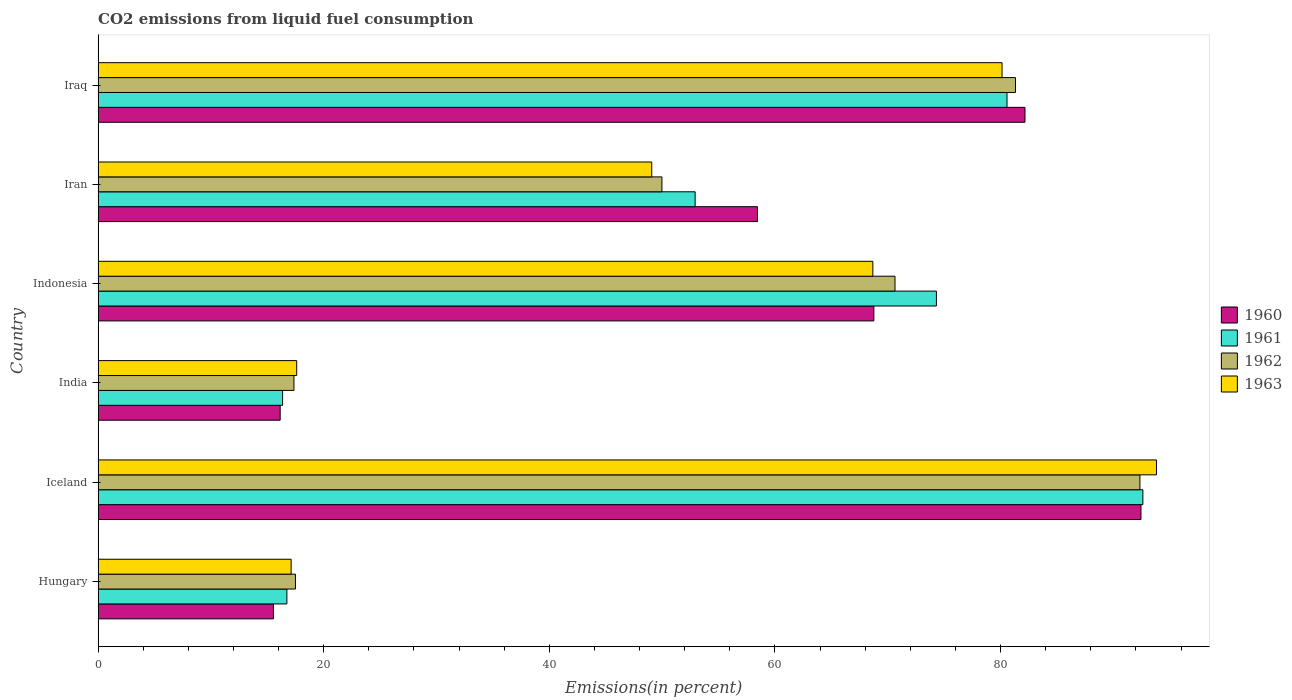How many bars are there on the 2nd tick from the top?
Ensure brevity in your answer.  4. How many bars are there on the 1st tick from the bottom?
Offer a terse response. 4. What is the label of the 1st group of bars from the top?
Your answer should be compact. Iraq. What is the total CO2 emitted in 1961 in Iran?
Make the answer very short. 52.93. Across all countries, what is the maximum total CO2 emitted in 1960?
Ensure brevity in your answer.  92.45. Across all countries, what is the minimum total CO2 emitted in 1961?
Provide a short and direct response. 16.35. In which country was the total CO2 emitted in 1960 maximum?
Your response must be concise. Iceland. What is the total total CO2 emitted in 1961 in the graph?
Your response must be concise. 333.52. What is the difference between the total CO2 emitted in 1962 in India and that in Iraq?
Offer a terse response. -63.96. What is the difference between the total CO2 emitted in 1961 in Iraq and the total CO2 emitted in 1962 in Indonesia?
Keep it short and to the point. 9.93. What is the average total CO2 emitted in 1960 per country?
Provide a succinct answer. 55.58. What is the difference between the total CO2 emitted in 1960 and total CO2 emitted in 1963 in Iceland?
Offer a very short reply. -1.37. In how many countries, is the total CO2 emitted in 1960 greater than 28 %?
Give a very brief answer. 4. What is the ratio of the total CO2 emitted in 1961 in Indonesia to that in Iran?
Give a very brief answer. 1.4. Is the difference between the total CO2 emitted in 1960 in India and Iraq greater than the difference between the total CO2 emitted in 1963 in India and Iraq?
Your answer should be very brief. No. What is the difference between the highest and the second highest total CO2 emitted in 1961?
Your answer should be compact. 12.05. What is the difference between the highest and the lowest total CO2 emitted in 1960?
Provide a succinct answer. 76.91. Is the sum of the total CO2 emitted in 1963 in Hungary and Indonesia greater than the maximum total CO2 emitted in 1962 across all countries?
Your response must be concise. No. Is it the case that in every country, the sum of the total CO2 emitted in 1960 and total CO2 emitted in 1961 is greater than the sum of total CO2 emitted in 1962 and total CO2 emitted in 1963?
Provide a succinct answer. No. Is it the case that in every country, the sum of the total CO2 emitted in 1963 and total CO2 emitted in 1961 is greater than the total CO2 emitted in 1962?
Provide a short and direct response. Yes. How many countries are there in the graph?
Give a very brief answer. 6. What is the difference between two consecutive major ticks on the X-axis?
Your response must be concise. 20. Does the graph contain grids?
Offer a terse response. No. What is the title of the graph?
Offer a terse response. CO2 emissions from liquid fuel consumption. Does "1983" appear as one of the legend labels in the graph?
Ensure brevity in your answer.  No. What is the label or title of the X-axis?
Provide a short and direct response. Emissions(in percent). What is the label or title of the Y-axis?
Make the answer very short. Country. What is the Emissions(in percent) of 1960 in Hungary?
Keep it short and to the point. 15.54. What is the Emissions(in percent) of 1961 in Hungary?
Make the answer very short. 16.73. What is the Emissions(in percent) of 1962 in Hungary?
Keep it short and to the point. 17.49. What is the Emissions(in percent) of 1963 in Hungary?
Your answer should be compact. 17.11. What is the Emissions(in percent) in 1960 in Iceland?
Offer a terse response. 92.45. What is the Emissions(in percent) in 1961 in Iceland?
Ensure brevity in your answer.  92.62. What is the Emissions(in percent) of 1962 in Iceland?
Provide a short and direct response. 92.35. What is the Emissions(in percent) of 1963 in Iceland?
Ensure brevity in your answer.  93.82. What is the Emissions(in percent) in 1960 in India?
Your answer should be very brief. 16.14. What is the Emissions(in percent) in 1961 in India?
Ensure brevity in your answer.  16.35. What is the Emissions(in percent) in 1962 in India?
Provide a succinct answer. 17.36. What is the Emissions(in percent) of 1963 in India?
Provide a succinct answer. 17.61. What is the Emissions(in percent) of 1960 in Indonesia?
Your answer should be very brief. 68.77. What is the Emissions(in percent) in 1961 in Indonesia?
Your answer should be very brief. 74.31. What is the Emissions(in percent) in 1962 in Indonesia?
Provide a succinct answer. 70.64. What is the Emissions(in percent) in 1963 in Indonesia?
Offer a terse response. 68.68. What is the Emissions(in percent) of 1960 in Iran?
Make the answer very short. 58.45. What is the Emissions(in percent) in 1961 in Iran?
Offer a terse response. 52.93. What is the Emissions(in percent) of 1962 in Iran?
Your response must be concise. 49.98. What is the Emissions(in percent) in 1963 in Iran?
Provide a short and direct response. 49.08. What is the Emissions(in percent) in 1960 in Iraq?
Your answer should be very brief. 82.17. What is the Emissions(in percent) of 1961 in Iraq?
Make the answer very short. 80.57. What is the Emissions(in percent) in 1962 in Iraq?
Provide a succinct answer. 81.32. What is the Emissions(in percent) in 1963 in Iraq?
Make the answer very short. 80.13. Across all countries, what is the maximum Emissions(in percent) of 1960?
Ensure brevity in your answer.  92.45. Across all countries, what is the maximum Emissions(in percent) in 1961?
Offer a very short reply. 92.62. Across all countries, what is the maximum Emissions(in percent) in 1962?
Offer a very short reply. 92.35. Across all countries, what is the maximum Emissions(in percent) of 1963?
Your answer should be compact. 93.82. Across all countries, what is the minimum Emissions(in percent) in 1960?
Provide a succinct answer. 15.54. Across all countries, what is the minimum Emissions(in percent) of 1961?
Offer a very short reply. 16.35. Across all countries, what is the minimum Emissions(in percent) of 1962?
Provide a succinct answer. 17.36. Across all countries, what is the minimum Emissions(in percent) of 1963?
Provide a succinct answer. 17.11. What is the total Emissions(in percent) in 1960 in the graph?
Make the answer very short. 333.51. What is the total Emissions(in percent) of 1961 in the graph?
Offer a very short reply. 333.52. What is the total Emissions(in percent) in 1962 in the graph?
Keep it short and to the point. 329.16. What is the total Emissions(in percent) in 1963 in the graph?
Ensure brevity in your answer.  326.43. What is the difference between the Emissions(in percent) in 1960 in Hungary and that in Iceland?
Offer a terse response. -76.91. What is the difference between the Emissions(in percent) of 1961 in Hungary and that in Iceland?
Offer a terse response. -75.88. What is the difference between the Emissions(in percent) of 1962 in Hungary and that in Iceland?
Make the answer very short. -74.86. What is the difference between the Emissions(in percent) in 1963 in Hungary and that in Iceland?
Your response must be concise. -76.71. What is the difference between the Emissions(in percent) in 1960 in Hungary and that in India?
Keep it short and to the point. -0.6. What is the difference between the Emissions(in percent) of 1961 in Hungary and that in India?
Give a very brief answer. 0.38. What is the difference between the Emissions(in percent) of 1962 in Hungary and that in India?
Keep it short and to the point. 0.13. What is the difference between the Emissions(in percent) of 1963 in Hungary and that in India?
Provide a succinct answer. -0.5. What is the difference between the Emissions(in percent) in 1960 in Hungary and that in Indonesia?
Your answer should be very brief. -53.23. What is the difference between the Emissions(in percent) in 1961 in Hungary and that in Indonesia?
Your response must be concise. -57.58. What is the difference between the Emissions(in percent) of 1962 in Hungary and that in Indonesia?
Your answer should be very brief. -53.15. What is the difference between the Emissions(in percent) in 1963 in Hungary and that in Indonesia?
Offer a terse response. -51.57. What is the difference between the Emissions(in percent) in 1960 in Hungary and that in Iran?
Offer a terse response. -42.91. What is the difference between the Emissions(in percent) of 1961 in Hungary and that in Iran?
Your answer should be very brief. -36.19. What is the difference between the Emissions(in percent) in 1962 in Hungary and that in Iran?
Provide a succinct answer. -32.49. What is the difference between the Emissions(in percent) in 1963 in Hungary and that in Iran?
Your response must be concise. -31.97. What is the difference between the Emissions(in percent) in 1960 in Hungary and that in Iraq?
Give a very brief answer. -66.62. What is the difference between the Emissions(in percent) in 1961 in Hungary and that in Iraq?
Make the answer very short. -63.84. What is the difference between the Emissions(in percent) of 1962 in Hungary and that in Iraq?
Your answer should be compact. -63.83. What is the difference between the Emissions(in percent) of 1963 in Hungary and that in Iraq?
Ensure brevity in your answer.  -63.02. What is the difference between the Emissions(in percent) of 1960 in Iceland and that in India?
Offer a terse response. 76.31. What is the difference between the Emissions(in percent) of 1961 in Iceland and that in India?
Your response must be concise. 76.26. What is the difference between the Emissions(in percent) of 1962 in Iceland and that in India?
Give a very brief answer. 74.99. What is the difference between the Emissions(in percent) in 1963 in Iceland and that in India?
Provide a succinct answer. 76.21. What is the difference between the Emissions(in percent) in 1960 in Iceland and that in Indonesia?
Your answer should be very brief. 23.68. What is the difference between the Emissions(in percent) in 1961 in Iceland and that in Indonesia?
Your answer should be compact. 18.3. What is the difference between the Emissions(in percent) of 1962 in Iceland and that in Indonesia?
Offer a very short reply. 21.71. What is the difference between the Emissions(in percent) in 1963 in Iceland and that in Indonesia?
Give a very brief answer. 25.14. What is the difference between the Emissions(in percent) of 1960 in Iceland and that in Iran?
Offer a very short reply. 34. What is the difference between the Emissions(in percent) of 1961 in Iceland and that in Iran?
Provide a short and direct response. 39.69. What is the difference between the Emissions(in percent) in 1962 in Iceland and that in Iran?
Give a very brief answer. 42.37. What is the difference between the Emissions(in percent) in 1963 in Iceland and that in Iran?
Your response must be concise. 44.74. What is the difference between the Emissions(in percent) of 1960 in Iceland and that in Iraq?
Make the answer very short. 10.28. What is the difference between the Emissions(in percent) of 1961 in Iceland and that in Iraq?
Give a very brief answer. 12.05. What is the difference between the Emissions(in percent) in 1962 in Iceland and that in Iraq?
Ensure brevity in your answer.  11.03. What is the difference between the Emissions(in percent) in 1963 in Iceland and that in Iraq?
Your answer should be very brief. 13.69. What is the difference between the Emissions(in percent) in 1960 in India and that in Indonesia?
Your response must be concise. -52.63. What is the difference between the Emissions(in percent) of 1961 in India and that in Indonesia?
Ensure brevity in your answer.  -57.96. What is the difference between the Emissions(in percent) in 1962 in India and that in Indonesia?
Your answer should be very brief. -53.28. What is the difference between the Emissions(in percent) of 1963 in India and that in Indonesia?
Keep it short and to the point. -51.07. What is the difference between the Emissions(in percent) in 1960 in India and that in Iran?
Provide a short and direct response. -42.31. What is the difference between the Emissions(in percent) of 1961 in India and that in Iran?
Provide a succinct answer. -36.57. What is the difference between the Emissions(in percent) in 1962 in India and that in Iran?
Your response must be concise. -32.62. What is the difference between the Emissions(in percent) in 1963 in India and that in Iran?
Your response must be concise. -31.47. What is the difference between the Emissions(in percent) of 1960 in India and that in Iraq?
Ensure brevity in your answer.  -66.03. What is the difference between the Emissions(in percent) in 1961 in India and that in Iraq?
Your response must be concise. -64.22. What is the difference between the Emissions(in percent) in 1962 in India and that in Iraq?
Ensure brevity in your answer.  -63.96. What is the difference between the Emissions(in percent) in 1963 in India and that in Iraq?
Provide a short and direct response. -62.53. What is the difference between the Emissions(in percent) in 1960 in Indonesia and that in Iran?
Your answer should be very brief. 10.32. What is the difference between the Emissions(in percent) in 1961 in Indonesia and that in Iran?
Provide a short and direct response. 21.39. What is the difference between the Emissions(in percent) in 1962 in Indonesia and that in Iran?
Provide a succinct answer. 20.66. What is the difference between the Emissions(in percent) in 1963 in Indonesia and that in Iran?
Your response must be concise. 19.6. What is the difference between the Emissions(in percent) of 1960 in Indonesia and that in Iraq?
Offer a terse response. -13.4. What is the difference between the Emissions(in percent) in 1961 in Indonesia and that in Iraq?
Ensure brevity in your answer.  -6.26. What is the difference between the Emissions(in percent) of 1962 in Indonesia and that in Iraq?
Your response must be concise. -10.68. What is the difference between the Emissions(in percent) in 1963 in Indonesia and that in Iraq?
Your answer should be very brief. -11.45. What is the difference between the Emissions(in percent) in 1960 in Iran and that in Iraq?
Ensure brevity in your answer.  -23.72. What is the difference between the Emissions(in percent) of 1961 in Iran and that in Iraq?
Keep it short and to the point. -27.65. What is the difference between the Emissions(in percent) of 1962 in Iran and that in Iraq?
Keep it short and to the point. -31.34. What is the difference between the Emissions(in percent) of 1963 in Iran and that in Iraq?
Offer a terse response. -31.06. What is the difference between the Emissions(in percent) in 1960 in Hungary and the Emissions(in percent) in 1961 in Iceland?
Make the answer very short. -77.08. What is the difference between the Emissions(in percent) of 1960 in Hungary and the Emissions(in percent) of 1962 in Iceland?
Your answer should be compact. -76.81. What is the difference between the Emissions(in percent) of 1960 in Hungary and the Emissions(in percent) of 1963 in Iceland?
Ensure brevity in your answer.  -78.28. What is the difference between the Emissions(in percent) in 1961 in Hungary and the Emissions(in percent) in 1962 in Iceland?
Keep it short and to the point. -75.62. What is the difference between the Emissions(in percent) of 1961 in Hungary and the Emissions(in percent) of 1963 in Iceland?
Your answer should be compact. -77.09. What is the difference between the Emissions(in percent) of 1962 in Hungary and the Emissions(in percent) of 1963 in Iceland?
Keep it short and to the point. -76.33. What is the difference between the Emissions(in percent) of 1960 in Hungary and the Emissions(in percent) of 1961 in India?
Ensure brevity in your answer.  -0.81. What is the difference between the Emissions(in percent) of 1960 in Hungary and the Emissions(in percent) of 1962 in India?
Offer a terse response. -1.82. What is the difference between the Emissions(in percent) in 1960 in Hungary and the Emissions(in percent) in 1963 in India?
Give a very brief answer. -2.06. What is the difference between the Emissions(in percent) of 1961 in Hungary and the Emissions(in percent) of 1962 in India?
Your answer should be compact. -0.63. What is the difference between the Emissions(in percent) in 1961 in Hungary and the Emissions(in percent) in 1963 in India?
Ensure brevity in your answer.  -0.87. What is the difference between the Emissions(in percent) in 1962 in Hungary and the Emissions(in percent) in 1963 in India?
Offer a terse response. -0.11. What is the difference between the Emissions(in percent) in 1960 in Hungary and the Emissions(in percent) in 1961 in Indonesia?
Give a very brief answer. -58.77. What is the difference between the Emissions(in percent) of 1960 in Hungary and the Emissions(in percent) of 1962 in Indonesia?
Your answer should be very brief. -55.1. What is the difference between the Emissions(in percent) in 1960 in Hungary and the Emissions(in percent) in 1963 in Indonesia?
Keep it short and to the point. -53.14. What is the difference between the Emissions(in percent) of 1961 in Hungary and the Emissions(in percent) of 1962 in Indonesia?
Your answer should be very brief. -53.91. What is the difference between the Emissions(in percent) of 1961 in Hungary and the Emissions(in percent) of 1963 in Indonesia?
Keep it short and to the point. -51.94. What is the difference between the Emissions(in percent) of 1962 in Hungary and the Emissions(in percent) of 1963 in Indonesia?
Your response must be concise. -51.19. What is the difference between the Emissions(in percent) in 1960 in Hungary and the Emissions(in percent) in 1961 in Iran?
Provide a succinct answer. -37.38. What is the difference between the Emissions(in percent) of 1960 in Hungary and the Emissions(in percent) of 1962 in Iran?
Offer a very short reply. -34.44. What is the difference between the Emissions(in percent) in 1960 in Hungary and the Emissions(in percent) in 1963 in Iran?
Your answer should be very brief. -33.54. What is the difference between the Emissions(in percent) of 1961 in Hungary and the Emissions(in percent) of 1962 in Iran?
Keep it short and to the point. -33.25. What is the difference between the Emissions(in percent) in 1961 in Hungary and the Emissions(in percent) in 1963 in Iran?
Offer a terse response. -32.34. What is the difference between the Emissions(in percent) of 1962 in Hungary and the Emissions(in percent) of 1963 in Iran?
Your response must be concise. -31.58. What is the difference between the Emissions(in percent) of 1960 in Hungary and the Emissions(in percent) of 1961 in Iraq?
Keep it short and to the point. -65.03. What is the difference between the Emissions(in percent) of 1960 in Hungary and the Emissions(in percent) of 1962 in Iraq?
Keep it short and to the point. -65.78. What is the difference between the Emissions(in percent) of 1960 in Hungary and the Emissions(in percent) of 1963 in Iraq?
Ensure brevity in your answer.  -64.59. What is the difference between the Emissions(in percent) in 1961 in Hungary and the Emissions(in percent) in 1962 in Iraq?
Provide a short and direct response. -64.59. What is the difference between the Emissions(in percent) of 1961 in Hungary and the Emissions(in percent) of 1963 in Iraq?
Provide a succinct answer. -63.4. What is the difference between the Emissions(in percent) of 1962 in Hungary and the Emissions(in percent) of 1963 in Iraq?
Provide a succinct answer. -62.64. What is the difference between the Emissions(in percent) of 1960 in Iceland and the Emissions(in percent) of 1961 in India?
Your answer should be very brief. 76.09. What is the difference between the Emissions(in percent) of 1960 in Iceland and the Emissions(in percent) of 1962 in India?
Offer a very short reply. 75.09. What is the difference between the Emissions(in percent) in 1960 in Iceland and the Emissions(in percent) in 1963 in India?
Your answer should be very brief. 74.84. What is the difference between the Emissions(in percent) of 1961 in Iceland and the Emissions(in percent) of 1962 in India?
Your answer should be very brief. 75.26. What is the difference between the Emissions(in percent) of 1961 in Iceland and the Emissions(in percent) of 1963 in India?
Give a very brief answer. 75.01. What is the difference between the Emissions(in percent) in 1962 in Iceland and the Emissions(in percent) in 1963 in India?
Make the answer very short. 74.75. What is the difference between the Emissions(in percent) in 1960 in Iceland and the Emissions(in percent) in 1961 in Indonesia?
Offer a terse response. 18.13. What is the difference between the Emissions(in percent) of 1960 in Iceland and the Emissions(in percent) of 1962 in Indonesia?
Offer a terse response. 21.8. What is the difference between the Emissions(in percent) in 1960 in Iceland and the Emissions(in percent) in 1963 in Indonesia?
Ensure brevity in your answer.  23.77. What is the difference between the Emissions(in percent) of 1961 in Iceland and the Emissions(in percent) of 1962 in Indonesia?
Provide a short and direct response. 21.97. What is the difference between the Emissions(in percent) of 1961 in Iceland and the Emissions(in percent) of 1963 in Indonesia?
Give a very brief answer. 23.94. What is the difference between the Emissions(in percent) of 1962 in Iceland and the Emissions(in percent) of 1963 in Indonesia?
Provide a succinct answer. 23.68. What is the difference between the Emissions(in percent) in 1960 in Iceland and the Emissions(in percent) in 1961 in Iran?
Your answer should be compact. 39.52. What is the difference between the Emissions(in percent) of 1960 in Iceland and the Emissions(in percent) of 1962 in Iran?
Make the answer very short. 42.47. What is the difference between the Emissions(in percent) in 1960 in Iceland and the Emissions(in percent) in 1963 in Iran?
Offer a terse response. 43.37. What is the difference between the Emissions(in percent) in 1961 in Iceland and the Emissions(in percent) in 1962 in Iran?
Make the answer very short. 42.64. What is the difference between the Emissions(in percent) of 1961 in Iceland and the Emissions(in percent) of 1963 in Iran?
Provide a short and direct response. 43.54. What is the difference between the Emissions(in percent) in 1962 in Iceland and the Emissions(in percent) in 1963 in Iran?
Provide a succinct answer. 43.28. What is the difference between the Emissions(in percent) in 1960 in Iceland and the Emissions(in percent) in 1961 in Iraq?
Keep it short and to the point. 11.88. What is the difference between the Emissions(in percent) of 1960 in Iceland and the Emissions(in percent) of 1962 in Iraq?
Offer a very short reply. 11.12. What is the difference between the Emissions(in percent) in 1960 in Iceland and the Emissions(in percent) in 1963 in Iraq?
Offer a very short reply. 12.31. What is the difference between the Emissions(in percent) of 1961 in Iceland and the Emissions(in percent) of 1962 in Iraq?
Provide a succinct answer. 11.29. What is the difference between the Emissions(in percent) of 1961 in Iceland and the Emissions(in percent) of 1963 in Iraq?
Keep it short and to the point. 12.48. What is the difference between the Emissions(in percent) of 1962 in Iceland and the Emissions(in percent) of 1963 in Iraq?
Your answer should be compact. 12.22. What is the difference between the Emissions(in percent) of 1960 in India and the Emissions(in percent) of 1961 in Indonesia?
Offer a very short reply. -58.17. What is the difference between the Emissions(in percent) in 1960 in India and the Emissions(in percent) in 1962 in Indonesia?
Your answer should be compact. -54.5. What is the difference between the Emissions(in percent) in 1960 in India and the Emissions(in percent) in 1963 in Indonesia?
Make the answer very short. -52.54. What is the difference between the Emissions(in percent) of 1961 in India and the Emissions(in percent) of 1962 in Indonesia?
Offer a very short reply. -54.29. What is the difference between the Emissions(in percent) of 1961 in India and the Emissions(in percent) of 1963 in Indonesia?
Your answer should be compact. -52.32. What is the difference between the Emissions(in percent) in 1962 in India and the Emissions(in percent) in 1963 in Indonesia?
Offer a very short reply. -51.32. What is the difference between the Emissions(in percent) of 1960 in India and the Emissions(in percent) of 1961 in Iran?
Provide a succinct answer. -36.79. What is the difference between the Emissions(in percent) of 1960 in India and the Emissions(in percent) of 1962 in Iran?
Offer a very short reply. -33.84. What is the difference between the Emissions(in percent) of 1960 in India and the Emissions(in percent) of 1963 in Iran?
Your response must be concise. -32.94. What is the difference between the Emissions(in percent) of 1961 in India and the Emissions(in percent) of 1962 in Iran?
Your answer should be compact. -33.63. What is the difference between the Emissions(in percent) of 1961 in India and the Emissions(in percent) of 1963 in Iran?
Provide a short and direct response. -32.72. What is the difference between the Emissions(in percent) in 1962 in India and the Emissions(in percent) in 1963 in Iran?
Provide a short and direct response. -31.72. What is the difference between the Emissions(in percent) of 1960 in India and the Emissions(in percent) of 1961 in Iraq?
Offer a very short reply. -64.43. What is the difference between the Emissions(in percent) in 1960 in India and the Emissions(in percent) in 1962 in Iraq?
Your response must be concise. -65.18. What is the difference between the Emissions(in percent) in 1960 in India and the Emissions(in percent) in 1963 in Iraq?
Provide a succinct answer. -63.99. What is the difference between the Emissions(in percent) in 1961 in India and the Emissions(in percent) in 1962 in Iraq?
Your answer should be very brief. -64.97. What is the difference between the Emissions(in percent) in 1961 in India and the Emissions(in percent) in 1963 in Iraq?
Provide a short and direct response. -63.78. What is the difference between the Emissions(in percent) in 1962 in India and the Emissions(in percent) in 1963 in Iraq?
Provide a succinct answer. -62.77. What is the difference between the Emissions(in percent) in 1960 in Indonesia and the Emissions(in percent) in 1961 in Iran?
Give a very brief answer. 15.84. What is the difference between the Emissions(in percent) in 1960 in Indonesia and the Emissions(in percent) in 1962 in Iran?
Offer a terse response. 18.79. What is the difference between the Emissions(in percent) of 1960 in Indonesia and the Emissions(in percent) of 1963 in Iran?
Make the answer very short. 19.69. What is the difference between the Emissions(in percent) in 1961 in Indonesia and the Emissions(in percent) in 1962 in Iran?
Make the answer very short. 24.33. What is the difference between the Emissions(in percent) of 1961 in Indonesia and the Emissions(in percent) of 1963 in Iran?
Offer a terse response. 25.24. What is the difference between the Emissions(in percent) in 1962 in Indonesia and the Emissions(in percent) in 1963 in Iran?
Give a very brief answer. 21.57. What is the difference between the Emissions(in percent) of 1960 in Indonesia and the Emissions(in percent) of 1961 in Iraq?
Make the answer very short. -11.8. What is the difference between the Emissions(in percent) of 1960 in Indonesia and the Emissions(in percent) of 1962 in Iraq?
Your response must be concise. -12.56. What is the difference between the Emissions(in percent) of 1960 in Indonesia and the Emissions(in percent) of 1963 in Iraq?
Your response must be concise. -11.36. What is the difference between the Emissions(in percent) in 1961 in Indonesia and the Emissions(in percent) in 1962 in Iraq?
Provide a succinct answer. -7.01. What is the difference between the Emissions(in percent) in 1961 in Indonesia and the Emissions(in percent) in 1963 in Iraq?
Keep it short and to the point. -5.82. What is the difference between the Emissions(in percent) in 1962 in Indonesia and the Emissions(in percent) in 1963 in Iraq?
Offer a terse response. -9.49. What is the difference between the Emissions(in percent) of 1960 in Iran and the Emissions(in percent) of 1961 in Iraq?
Offer a terse response. -22.12. What is the difference between the Emissions(in percent) in 1960 in Iran and the Emissions(in percent) in 1962 in Iraq?
Your answer should be very brief. -22.88. What is the difference between the Emissions(in percent) of 1960 in Iran and the Emissions(in percent) of 1963 in Iraq?
Your answer should be compact. -21.68. What is the difference between the Emissions(in percent) in 1961 in Iran and the Emissions(in percent) in 1962 in Iraq?
Provide a short and direct response. -28.4. What is the difference between the Emissions(in percent) of 1961 in Iran and the Emissions(in percent) of 1963 in Iraq?
Provide a short and direct response. -27.21. What is the difference between the Emissions(in percent) in 1962 in Iran and the Emissions(in percent) in 1963 in Iraq?
Offer a terse response. -30.15. What is the average Emissions(in percent) in 1960 per country?
Your response must be concise. 55.59. What is the average Emissions(in percent) in 1961 per country?
Provide a short and direct response. 55.59. What is the average Emissions(in percent) of 1962 per country?
Your answer should be compact. 54.86. What is the average Emissions(in percent) of 1963 per country?
Make the answer very short. 54.4. What is the difference between the Emissions(in percent) of 1960 and Emissions(in percent) of 1961 in Hungary?
Make the answer very short. -1.19. What is the difference between the Emissions(in percent) in 1960 and Emissions(in percent) in 1962 in Hungary?
Your response must be concise. -1.95. What is the difference between the Emissions(in percent) in 1960 and Emissions(in percent) in 1963 in Hungary?
Offer a very short reply. -1.57. What is the difference between the Emissions(in percent) of 1961 and Emissions(in percent) of 1962 in Hungary?
Give a very brief answer. -0.76. What is the difference between the Emissions(in percent) of 1961 and Emissions(in percent) of 1963 in Hungary?
Give a very brief answer. -0.38. What is the difference between the Emissions(in percent) of 1962 and Emissions(in percent) of 1963 in Hungary?
Your response must be concise. 0.38. What is the difference between the Emissions(in percent) in 1960 and Emissions(in percent) in 1961 in Iceland?
Your answer should be compact. -0.17. What is the difference between the Emissions(in percent) of 1960 and Emissions(in percent) of 1962 in Iceland?
Your answer should be compact. 0.09. What is the difference between the Emissions(in percent) in 1960 and Emissions(in percent) in 1963 in Iceland?
Ensure brevity in your answer.  -1.37. What is the difference between the Emissions(in percent) in 1961 and Emissions(in percent) in 1962 in Iceland?
Your answer should be compact. 0.26. What is the difference between the Emissions(in percent) in 1961 and Emissions(in percent) in 1963 in Iceland?
Provide a short and direct response. -1.2. What is the difference between the Emissions(in percent) of 1962 and Emissions(in percent) of 1963 in Iceland?
Your response must be concise. -1.47. What is the difference between the Emissions(in percent) of 1960 and Emissions(in percent) of 1961 in India?
Keep it short and to the point. -0.22. What is the difference between the Emissions(in percent) in 1960 and Emissions(in percent) in 1962 in India?
Make the answer very short. -1.22. What is the difference between the Emissions(in percent) in 1960 and Emissions(in percent) in 1963 in India?
Your answer should be compact. -1.47. What is the difference between the Emissions(in percent) of 1961 and Emissions(in percent) of 1962 in India?
Your answer should be compact. -1.01. What is the difference between the Emissions(in percent) in 1961 and Emissions(in percent) in 1963 in India?
Your answer should be very brief. -1.25. What is the difference between the Emissions(in percent) of 1962 and Emissions(in percent) of 1963 in India?
Keep it short and to the point. -0.25. What is the difference between the Emissions(in percent) of 1960 and Emissions(in percent) of 1961 in Indonesia?
Make the answer very short. -5.54. What is the difference between the Emissions(in percent) of 1960 and Emissions(in percent) of 1962 in Indonesia?
Provide a succinct answer. -1.87. What is the difference between the Emissions(in percent) in 1960 and Emissions(in percent) in 1963 in Indonesia?
Your answer should be very brief. 0.09. What is the difference between the Emissions(in percent) of 1961 and Emissions(in percent) of 1962 in Indonesia?
Your answer should be very brief. 3.67. What is the difference between the Emissions(in percent) of 1961 and Emissions(in percent) of 1963 in Indonesia?
Keep it short and to the point. 5.63. What is the difference between the Emissions(in percent) in 1962 and Emissions(in percent) in 1963 in Indonesia?
Your answer should be very brief. 1.96. What is the difference between the Emissions(in percent) of 1960 and Emissions(in percent) of 1961 in Iran?
Your answer should be very brief. 5.52. What is the difference between the Emissions(in percent) of 1960 and Emissions(in percent) of 1962 in Iran?
Give a very brief answer. 8.47. What is the difference between the Emissions(in percent) of 1960 and Emissions(in percent) of 1963 in Iran?
Keep it short and to the point. 9.37. What is the difference between the Emissions(in percent) in 1961 and Emissions(in percent) in 1962 in Iran?
Keep it short and to the point. 2.94. What is the difference between the Emissions(in percent) in 1961 and Emissions(in percent) in 1963 in Iran?
Keep it short and to the point. 3.85. What is the difference between the Emissions(in percent) of 1962 and Emissions(in percent) of 1963 in Iran?
Keep it short and to the point. 0.9. What is the difference between the Emissions(in percent) in 1960 and Emissions(in percent) in 1961 in Iraq?
Keep it short and to the point. 1.59. What is the difference between the Emissions(in percent) in 1960 and Emissions(in percent) in 1962 in Iraq?
Give a very brief answer. 0.84. What is the difference between the Emissions(in percent) in 1960 and Emissions(in percent) in 1963 in Iraq?
Offer a very short reply. 2.03. What is the difference between the Emissions(in percent) in 1961 and Emissions(in percent) in 1962 in Iraq?
Your response must be concise. -0.75. What is the difference between the Emissions(in percent) of 1961 and Emissions(in percent) of 1963 in Iraq?
Give a very brief answer. 0.44. What is the difference between the Emissions(in percent) of 1962 and Emissions(in percent) of 1963 in Iraq?
Provide a short and direct response. 1.19. What is the ratio of the Emissions(in percent) of 1960 in Hungary to that in Iceland?
Your answer should be compact. 0.17. What is the ratio of the Emissions(in percent) in 1961 in Hungary to that in Iceland?
Your response must be concise. 0.18. What is the ratio of the Emissions(in percent) in 1962 in Hungary to that in Iceland?
Ensure brevity in your answer.  0.19. What is the ratio of the Emissions(in percent) of 1963 in Hungary to that in Iceland?
Your response must be concise. 0.18. What is the ratio of the Emissions(in percent) of 1960 in Hungary to that in India?
Your answer should be compact. 0.96. What is the ratio of the Emissions(in percent) of 1961 in Hungary to that in India?
Make the answer very short. 1.02. What is the ratio of the Emissions(in percent) of 1962 in Hungary to that in India?
Provide a succinct answer. 1.01. What is the ratio of the Emissions(in percent) in 1963 in Hungary to that in India?
Make the answer very short. 0.97. What is the ratio of the Emissions(in percent) in 1960 in Hungary to that in Indonesia?
Your answer should be very brief. 0.23. What is the ratio of the Emissions(in percent) of 1961 in Hungary to that in Indonesia?
Your response must be concise. 0.23. What is the ratio of the Emissions(in percent) of 1962 in Hungary to that in Indonesia?
Ensure brevity in your answer.  0.25. What is the ratio of the Emissions(in percent) in 1963 in Hungary to that in Indonesia?
Your answer should be compact. 0.25. What is the ratio of the Emissions(in percent) in 1960 in Hungary to that in Iran?
Offer a terse response. 0.27. What is the ratio of the Emissions(in percent) of 1961 in Hungary to that in Iran?
Keep it short and to the point. 0.32. What is the ratio of the Emissions(in percent) in 1962 in Hungary to that in Iran?
Offer a terse response. 0.35. What is the ratio of the Emissions(in percent) of 1963 in Hungary to that in Iran?
Your answer should be very brief. 0.35. What is the ratio of the Emissions(in percent) in 1960 in Hungary to that in Iraq?
Ensure brevity in your answer.  0.19. What is the ratio of the Emissions(in percent) in 1961 in Hungary to that in Iraq?
Make the answer very short. 0.21. What is the ratio of the Emissions(in percent) in 1962 in Hungary to that in Iraq?
Make the answer very short. 0.22. What is the ratio of the Emissions(in percent) in 1963 in Hungary to that in Iraq?
Provide a succinct answer. 0.21. What is the ratio of the Emissions(in percent) in 1960 in Iceland to that in India?
Offer a very short reply. 5.73. What is the ratio of the Emissions(in percent) in 1961 in Iceland to that in India?
Your answer should be compact. 5.66. What is the ratio of the Emissions(in percent) in 1962 in Iceland to that in India?
Keep it short and to the point. 5.32. What is the ratio of the Emissions(in percent) in 1963 in Iceland to that in India?
Provide a short and direct response. 5.33. What is the ratio of the Emissions(in percent) in 1960 in Iceland to that in Indonesia?
Your answer should be very brief. 1.34. What is the ratio of the Emissions(in percent) of 1961 in Iceland to that in Indonesia?
Provide a short and direct response. 1.25. What is the ratio of the Emissions(in percent) of 1962 in Iceland to that in Indonesia?
Offer a very short reply. 1.31. What is the ratio of the Emissions(in percent) in 1963 in Iceland to that in Indonesia?
Provide a short and direct response. 1.37. What is the ratio of the Emissions(in percent) of 1960 in Iceland to that in Iran?
Provide a succinct answer. 1.58. What is the ratio of the Emissions(in percent) of 1962 in Iceland to that in Iran?
Give a very brief answer. 1.85. What is the ratio of the Emissions(in percent) of 1963 in Iceland to that in Iran?
Provide a succinct answer. 1.91. What is the ratio of the Emissions(in percent) in 1960 in Iceland to that in Iraq?
Keep it short and to the point. 1.13. What is the ratio of the Emissions(in percent) in 1961 in Iceland to that in Iraq?
Keep it short and to the point. 1.15. What is the ratio of the Emissions(in percent) of 1962 in Iceland to that in Iraq?
Your answer should be compact. 1.14. What is the ratio of the Emissions(in percent) of 1963 in Iceland to that in Iraq?
Provide a succinct answer. 1.17. What is the ratio of the Emissions(in percent) in 1960 in India to that in Indonesia?
Your response must be concise. 0.23. What is the ratio of the Emissions(in percent) of 1961 in India to that in Indonesia?
Your answer should be compact. 0.22. What is the ratio of the Emissions(in percent) in 1962 in India to that in Indonesia?
Your answer should be very brief. 0.25. What is the ratio of the Emissions(in percent) in 1963 in India to that in Indonesia?
Provide a succinct answer. 0.26. What is the ratio of the Emissions(in percent) of 1960 in India to that in Iran?
Offer a very short reply. 0.28. What is the ratio of the Emissions(in percent) of 1961 in India to that in Iran?
Provide a short and direct response. 0.31. What is the ratio of the Emissions(in percent) in 1962 in India to that in Iran?
Offer a very short reply. 0.35. What is the ratio of the Emissions(in percent) of 1963 in India to that in Iran?
Offer a very short reply. 0.36. What is the ratio of the Emissions(in percent) in 1960 in India to that in Iraq?
Your answer should be compact. 0.2. What is the ratio of the Emissions(in percent) in 1961 in India to that in Iraq?
Give a very brief answer. 0.2. What is the ratio of the Emissions(in percent) of 1962 in India to that in Iraq?
Your answer should be compact. 0.21. What is the ratio of the Emissions(in percent) in 1963 in India to that in Iraq?
Your answer should be very brief. 0.22. What is the ratio of the Emissions(in percent) in 1960 in Indonesia to that in Iran?
Your answer should be very brief. 1.18. What is the ratio of the Emissions(in percent) in 1961 in Indonesia to that in Iran?
Keep it short and to the point. 1.4. What is the ratio of the Emissions(in percent) in 1962 in Indonesia to that in Iran?
Your answer should be compact. 1.41. What is the ratio of the Emissions(in percent) in 1963 in Indonesia to that in Iran?
Provide a short and direct response. 1.4. What is the ratio of the Emissions(in percent) in 1960 in Indonesia to that in Iraq?
Your answer should be compact. 0.84. What is the ratio of the Emissions(in percent) of 1961 in Indonesia to that in Iraq?
Make the answer very short. 0.92. What is the ratio of the Emissions(in percent) of 1962 in Indonesia to that in Iraq?
Your answer should be very brief. 0.87. What is the ratio of the Emissions(in percent) in 1963 in Indonesia to that in Iraq?
Make the answer very short. 0.86. What is the ratio of the Emissions(in percent) of 1960 in Iran to that in Iraq?
Your response must be concise. 0.71. What is the ratio of the Emissions(in percent) in 1961 in Iran to that in Iraq?
Keep it short and to the point. 0.66. What is the ratio of the Emissions(in percent) in 1962 in Iran to that in Iraq?
Keep it short and to the point. 0.61. What is the ratio of the Emissions(in percent) of 1963 in Iran to that in Iraq?
Make the answer very short. 0.61. What is the difference between the highest and the second highest Emissions(in percent) in 1960?
Provide a succinct answer. 10.28. What is the difference between the highest and the second highest Emissions(in percent) in 1961?
Offer a terse response. 12.05. What is the difference between the highest and the second highest Emissions(in percent) in 1962?
Your response must be concise. 11.03. What is the difference between the highest and the second highest Emissions(in percent) of 1963?
Offer a very short reply. 13.69. What is the difference between the highest and the lowest Emissions(in percent) of 1960?
Keep it short and to the point. 76.91. What is the difference between the highest and the lowest Emissions(in percent) of 1961?
Your answer should be very brief. 76.26. What is the difference between the highest and the lowest Emissions(in percent) of 1962?
Make the answer very short. 74.99. What is the difference between the highest and the lowest Emissions(in percent) in 1963?
Make the answer very short. 76.71. 